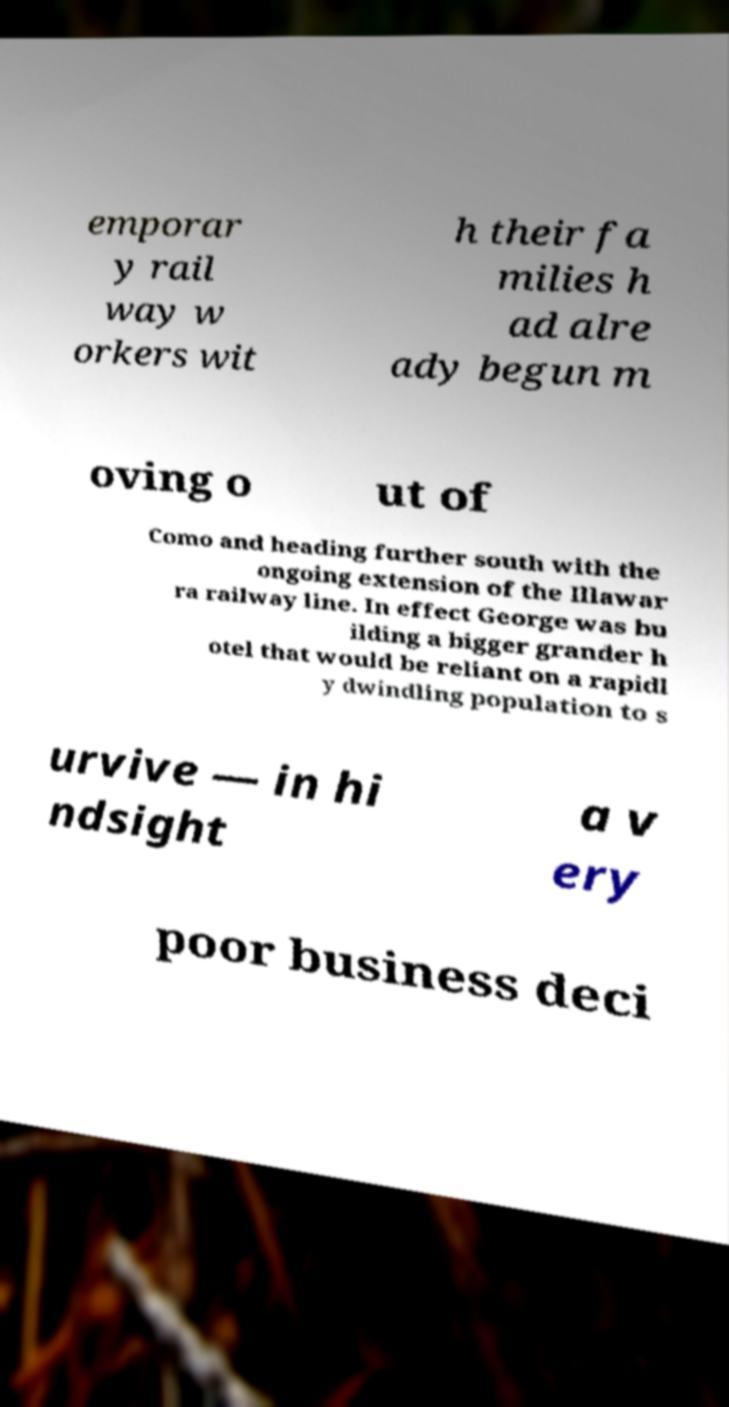What messages or text are displayed in this image? I need them in a readable, typed format. emporar y rail way w orkers wit h their fa milies h ad alre ady begun m oving o ut of Como and heading further south with the ongoing extension of the Illawar ra railway line. In effect George was bu ilding a bigger grander h otel that would be reliant on a rapidl y dwindling population to s urvive — in hi ndsight a v ery poor business deci 